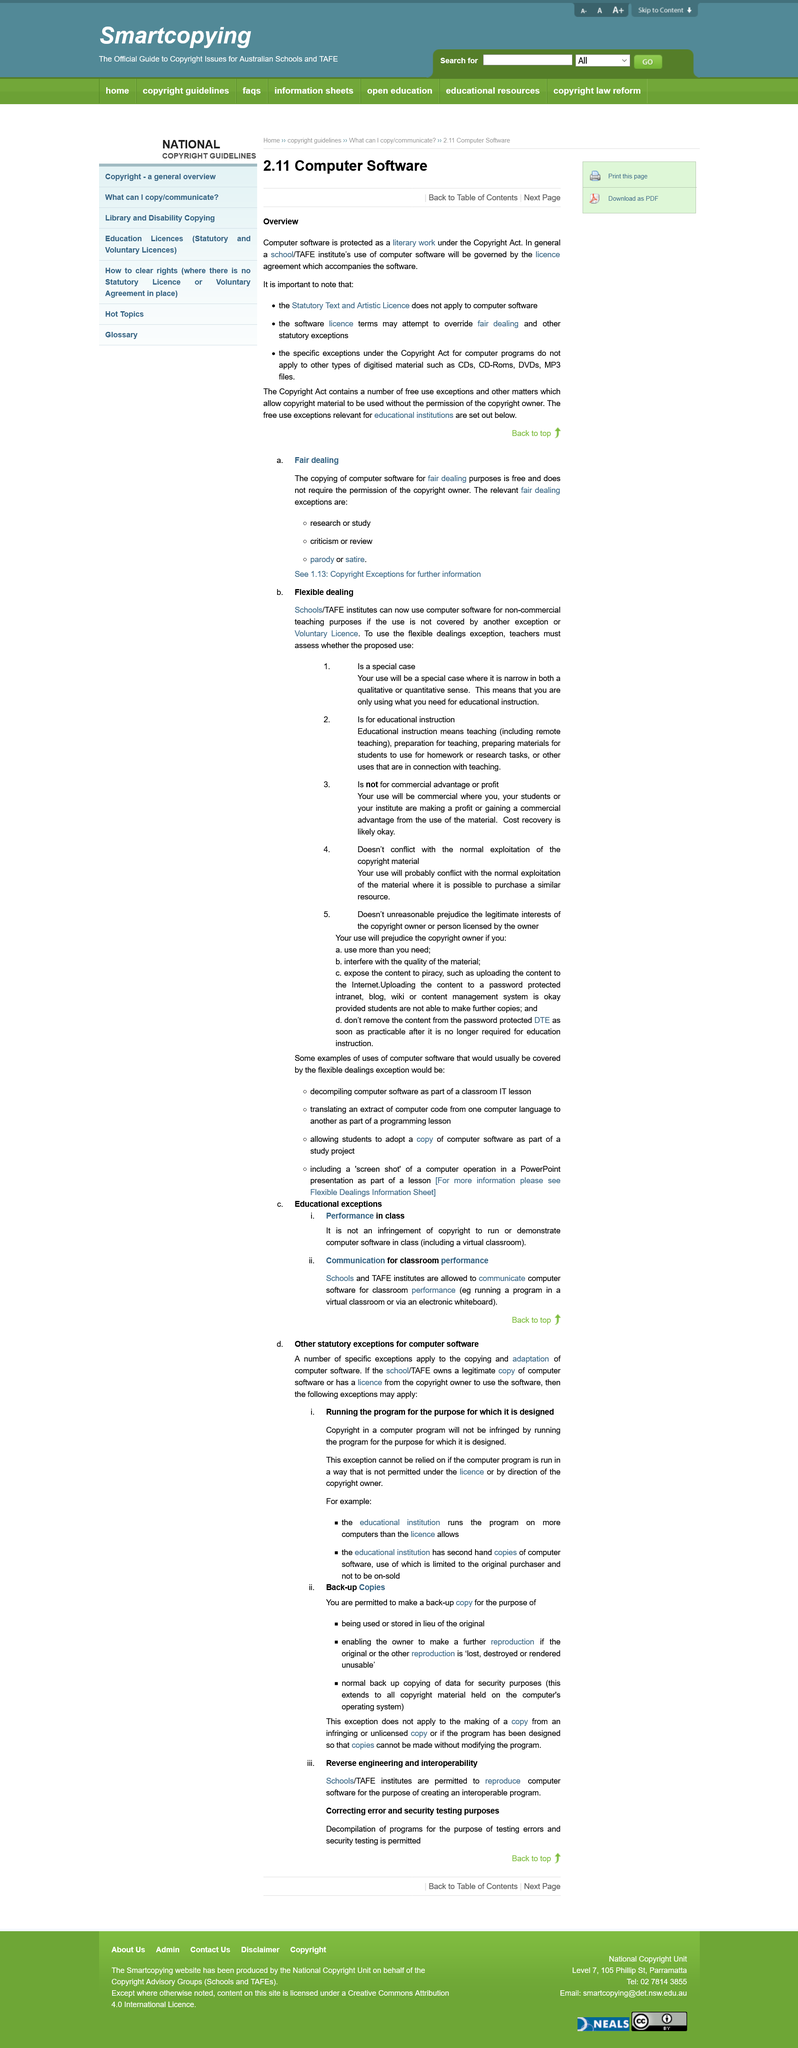Outline some significant characteristics in this image. Decompiling software as part of a classroom IT lesson is an example of flexible use. Using computer software for classroom performance, such as running a program in a virtual classroom or via an electric whiteboard, is an example of leveraging technology to enhance teaching and learning. Teachers can rely on the flexible dealings exception for computer software when the proposed use is a special case, such as for educational instruction. The relevant fair dealing exceptions for copying computer software are research or study, criticism or review, and parody or satire. It is not permissible to rely on the exception if the computer program is run in a manner that is not authorized by the license or by direction of the copyright owner. 